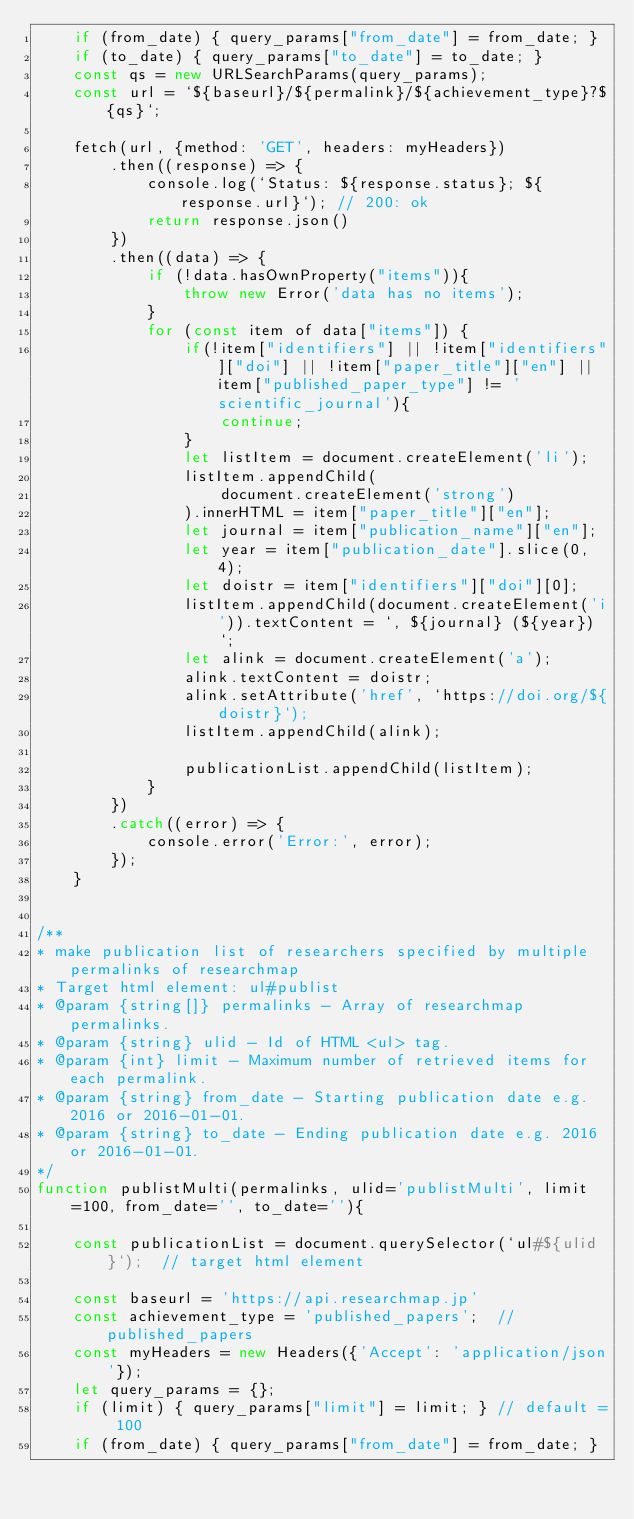<code> <loc_0><loc_0><loc_500><loc_500><_JavaScript_>    if (from_date) { query_params["from_date"] = from_date; }
    if (to_date) { query_params["to_date"] = to_date; }
    const qs = new URLSearchParams(query_params);
    const url = `${baseurl}/${permalink}/${achievement_type}?${qs}`;
    
    fetch(url, {method: 'GET', headers: myHeaders})
        .then((response) => {
            console.log(`Status: ${response.status}; ${response.url}`); // 200: ok
            return response.json()
        })
        .then((data) => {
            if (!data.hasOwnProperty("items")){
                throw new Error('data has no items');
            }
            for (const item of data["items"]) {
                if(!item["identifiers"] || !item["identifiers"]["doi"] || !item["paper_title"]["en"] || item["published_paper_type"] != 'scientific_journal'){
                    continue;
                }
                let listItem = document.createElement('li');
                listItem.appendChild(
                    document.createElement('strong')
                ).innerHTML = item["paper_title"]["en"];
                let journal = item["publication_name"]["en"];
                let year = item["publication_date"].slice(0, 4);
                let doistr = item["identifiers"]["doi"][0];
                listItem.appendChild(document.createElement('i')).textContent = `, ${journal} (${year}) `;
                let alink = document.createElement('a');
                alink.textContent = doistr;
                alink.setAttribute('href', `https://doi.org/${doistr}`);
                listItem.appendChild(alink);
                
                publicationList.appendChild(listItem);
            }
        })
        .catch((error) => {
            console.error('Error:', error);
        });
    }

    
/**
* make publication list of researchers specified by multiple permalinks of researchmap
* Target html element: ul#publist
* @param {string[]} permalinks - Array of researchmap permalinks.
* @param {string} ulid - Id of HTML <ul> tag.
* @param {int} limit - Maximum number of retrieved items for each permalink.
* @param {string} from_date - Starting publication date e.g. 2016 or 2016-01-01.
* @param {string} to_date - Ending publication date e.g. 2016 or 2016-01-01.
*/
function publistMulti(permalinks, ulid='publistMulti', limit=100, from_date='', to_date=''){

    const publicationList = document.querySelector(`ul#${ulid}`);  // target html element
    
    const baseurl = 'https://api.researchmap.jp'
    const achievement_type = 'published_papers';  // published_papers
    const myHeaders = new Headers({'Accept': 'application/json'});
    let query_params = {};
    if (limit) { query_params["limit"] = limit; } // default = 100
    if (from_date) { query_params["from_date"] = from_date; }</code> 